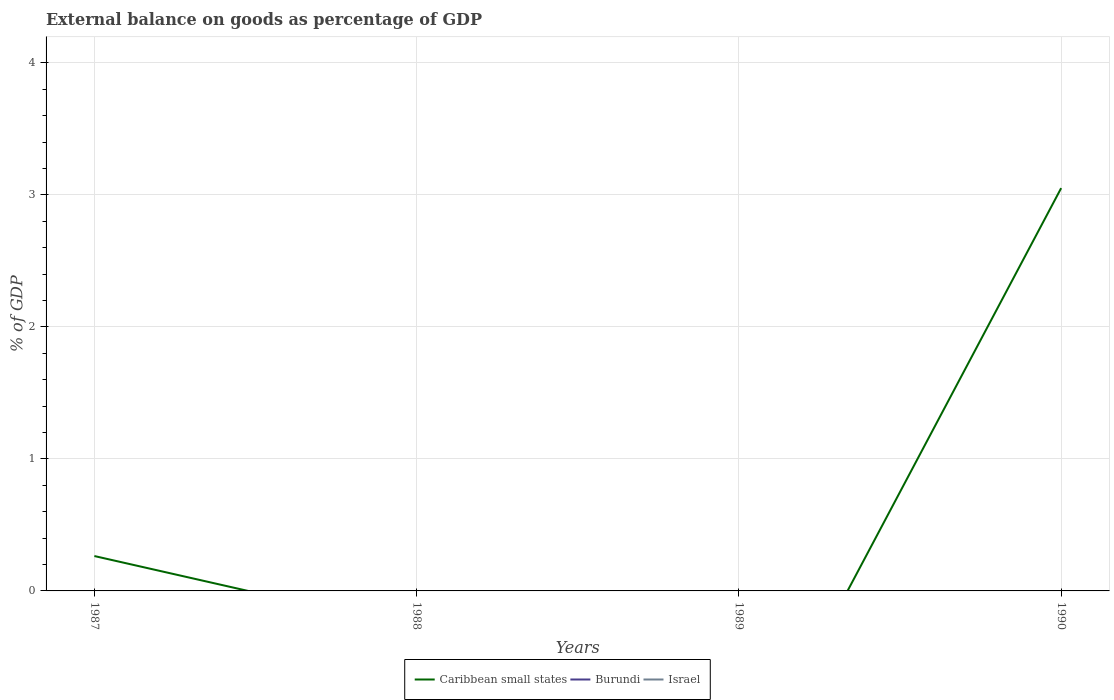What is the difference between the highest and the second highest external balance on goods as percentage of GDP in Caribbean small states?
Keep it short and to the point. 3.05. Is the external balance on goods as percentage of GDP in Caribbean small states strictly greater than the external balance on goods as percentage of GDP in Israel over the years?
Ensure brevity in your answer.  No. How many years are there in the graph?
Provide a succinct answer. 4. What is the difference between two consecutive major ticks on the Y-axis?
Offer a very short reply. 1. Does the graph contain grids?
Provide a succinct answer. Yes. Where does the legend appear in the graph?
Offer a terse response. Bottom center. What is the title of the graph?
Provide a succinct answer. External balance on goods as percentage of GDP. Does "Eritrea" appear as one of the legend labels in the graph?
Your answer should be very brief. No. What is the label or title of the X-axis?
Your answer should be compact. Years. What is the label or title of the Y-axis?
Your response must be concise. % of GDP. What is the % of GDP in Caribbean small states in 1987?
Your answer should be very brief. 0.26. What is the % of GDP in Caribbean small states in 1988?
Your response must be concise. 0. What is the % of GDP of Burundi in 1988?
Provide a short and direct response. 0. What is the % of GDP of Caribbean small states in 1989?
Provide a succinct answer. 0. What is the % of GDP of Caribbean small states in 1990?
Your answer should be very brief. 3.05. Across all years, what is the maximum % of GDP in Caribbean small states?
Your response must be concise. 3.05. What is the total % of GDP of Caribbean small states in the graph?
Provide a short and direct response. 3.31. What is the total % of GDP of Israel in the graph?
Provide a short and direct response. 0. What is the difference between the % of GDP of Caribbean small states in 1987 and that in 1990?
Provide a short and direct response. -2.79. What is the average % of GDP in Caribbean small states per year?
Provide a succinct answer. 0.83. What is the average % of GDP in Burundi per year?
Your answer should be very brief. 0. What is the average % of GDP of Israel per year?
Ensure brevity in your answer.  0. What is the ratio of the % of GDP in Caribbean small states in 1987 to that in 1990?
Offer a terse response. 0.09. What is the difference between the highest and the lowest % of GDP of Caribbean small states?
Make the answer very short. 3.05. 